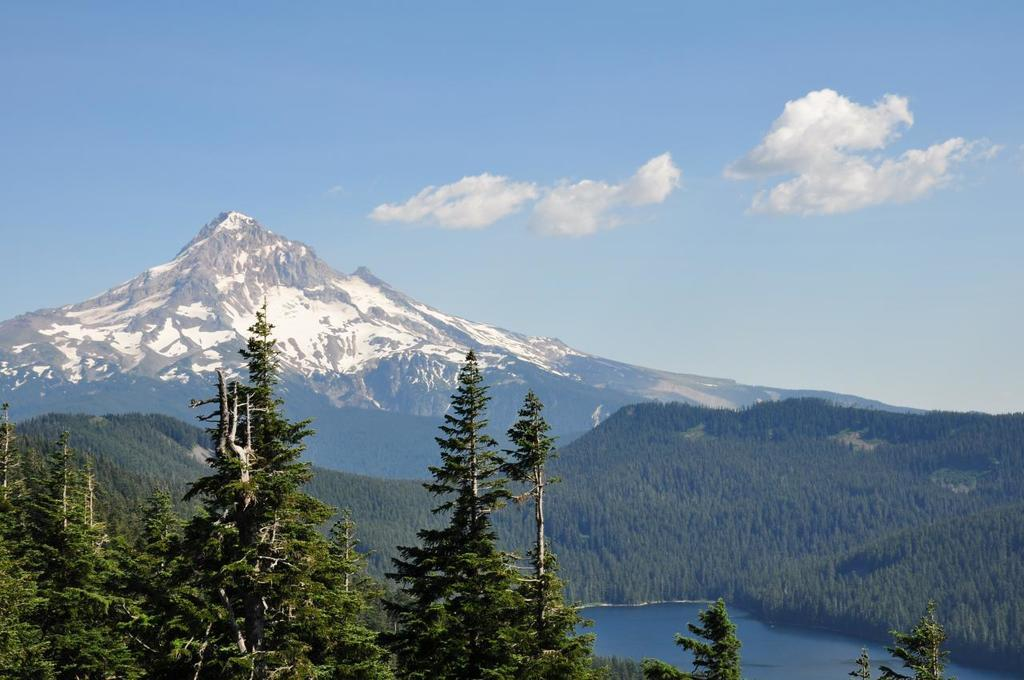What type of natural environment is depicted in the image? The image contains trees, water, mountains, and a sky with clouds, suggesting a natural landscape. Can you describe the water in the image? There is water visible in the image, but its specific characteristics are not mentioned in the facts. What is the background of the image? The sky is visible in the background of the image, with clouds present. What type of geographical feature can be seen in the image? Mountains are present in the image. What type of calculator can be seen on the mountain in the image? There is no calculator present in the image, and no objects are mentioned on the mountain. What type of marble is visible in the image? There is no marble present in the image; the facts mention trees, water, mountains, and a sky with clouds. 